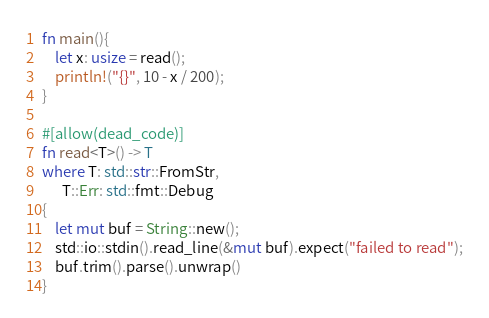Convert code to text. <code><loc_0><loc_0><loc_500><loc_500><_Rust_>fn main(){
    let x: usize = read();
    println!("{}", 10 - x / 200);
}

#[allow(dead_code)]
fn read<T>() -> T
where T: std::str::FromStr,
      T::Err: std::fmt::Debug
{
    let mut buf = String::new();
    std::io::stdin().read_line(&mut buf).expect("failed to read");
    buf.trim().parse().unwrap()
}
</code> 